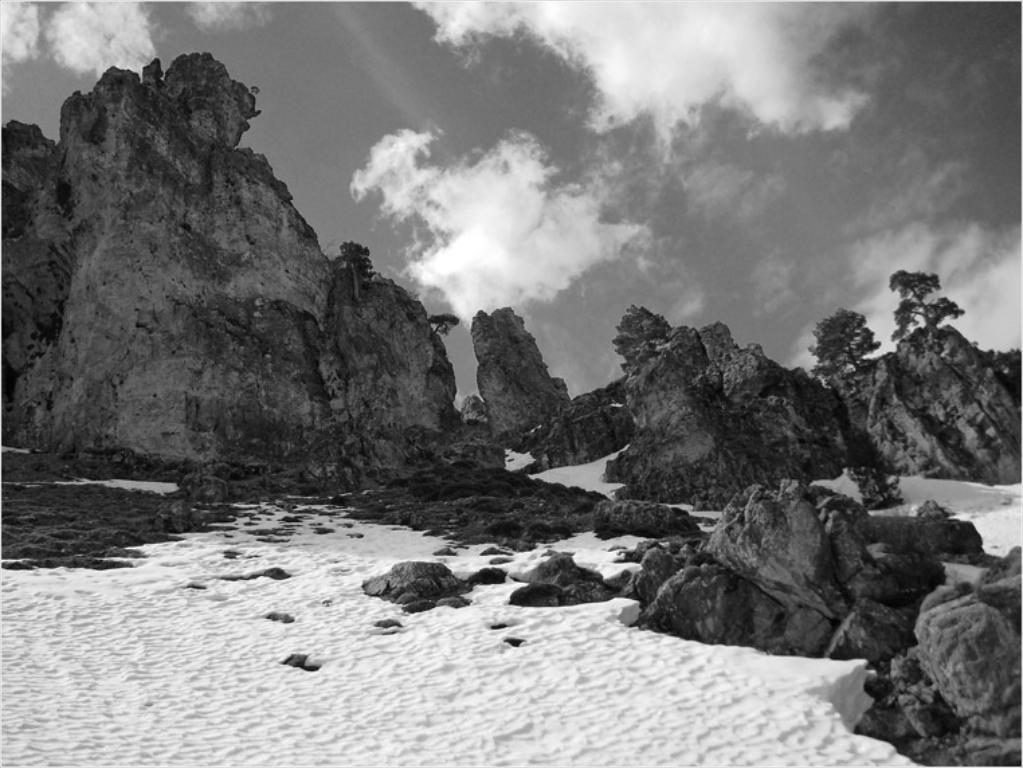What is the color scheme of the image? The image is black and white. What can be seen on the ground in the image? There is snow on the ground in the image. What type of natural feature is visible in the image? Rocks are visible in the image. What is visible in the background of the image? The sky is visible in the background of the image. What is the condition of the sky in the image? Clouds are present in the sky. What type of plant can be seen hanging from the curtain in the image? There is no plant or curtain present in the image; it is a black and white image with snow, rocks, and a sky with clouds. What type of store is visible in the background of the image? There is no store visible in the image; it is a natural scene with snow, rocks, and a sky with clouds. 